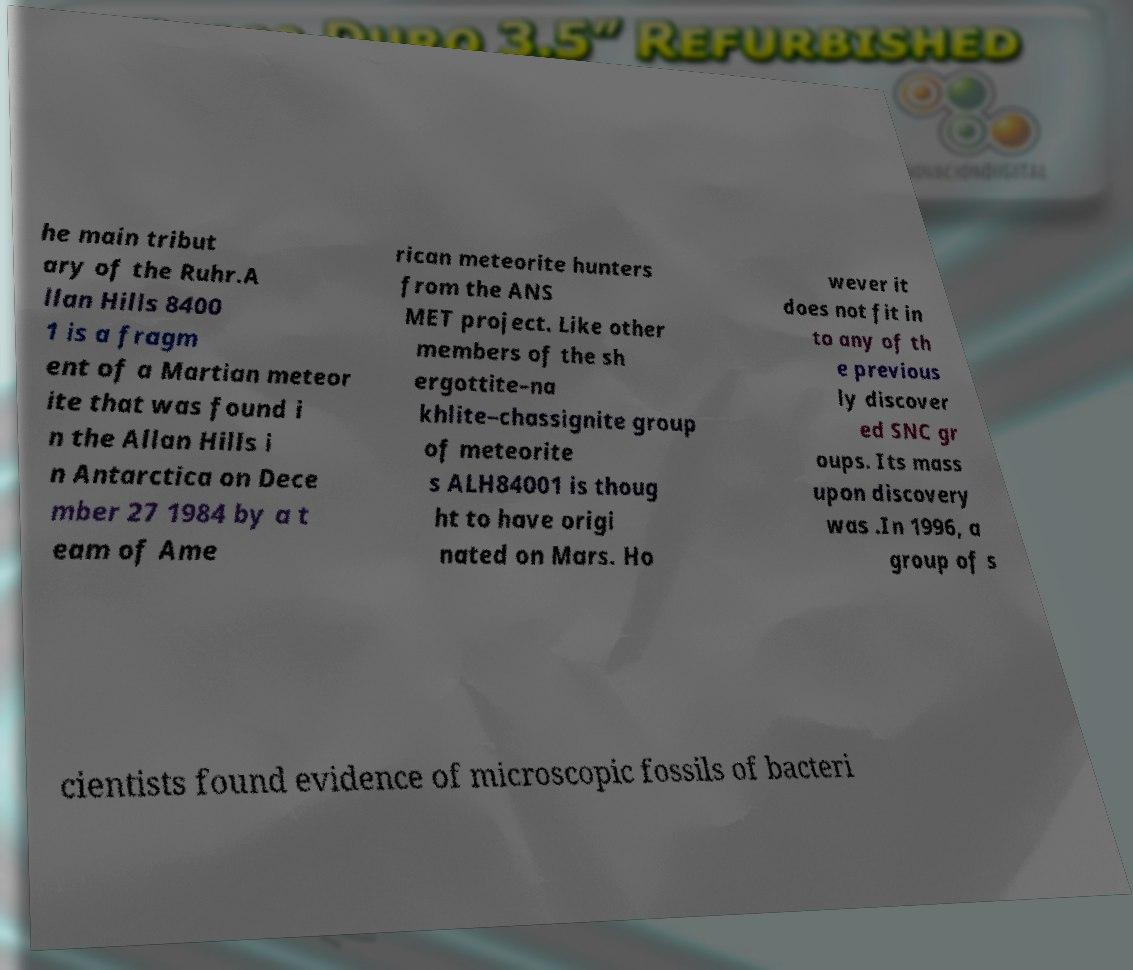Please identify and transcribe the text found in this image. he main tribut ary of the Ruhr.A llan Hills 8400 1 is a fragm ent of a Martian meteor ite that was found i n the Allan Hills i n Antarctica on Dece mber 27 1984 by a t eam of Ame rican meteorite hunters from the ANS MET project. Like other members of the sh ergottite–na khlite–chassignite group of meteorite s ALH84001 is thoug ht to have origi nated on Mars. Ho wever it does not fit in to any of th e previous ly discover ed SNC gr oups. Its mass upon discovery was .In 1996, a group of s cientists found evidence of microscopic fossils of bacteri 